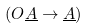<formula> <loc_0><loc_0><loc_500><loc_500>( O \underline { A } \rightarrow \underline { A } )</formula> 